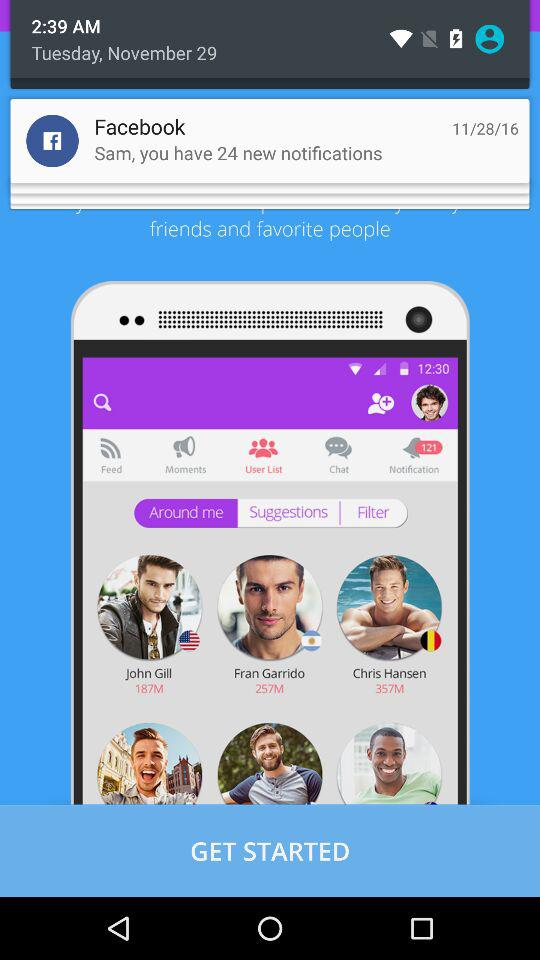How many notifications does the user have?
Answer the question using a single word or phrase. 24 